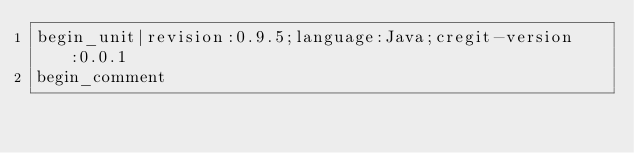<code> <loc_0><loc_0><loc_500><loc_500><_Java_>begin_unit|revision:0.9.5;language:Java;cregit-version:0.0.1
begin_comment</code> 